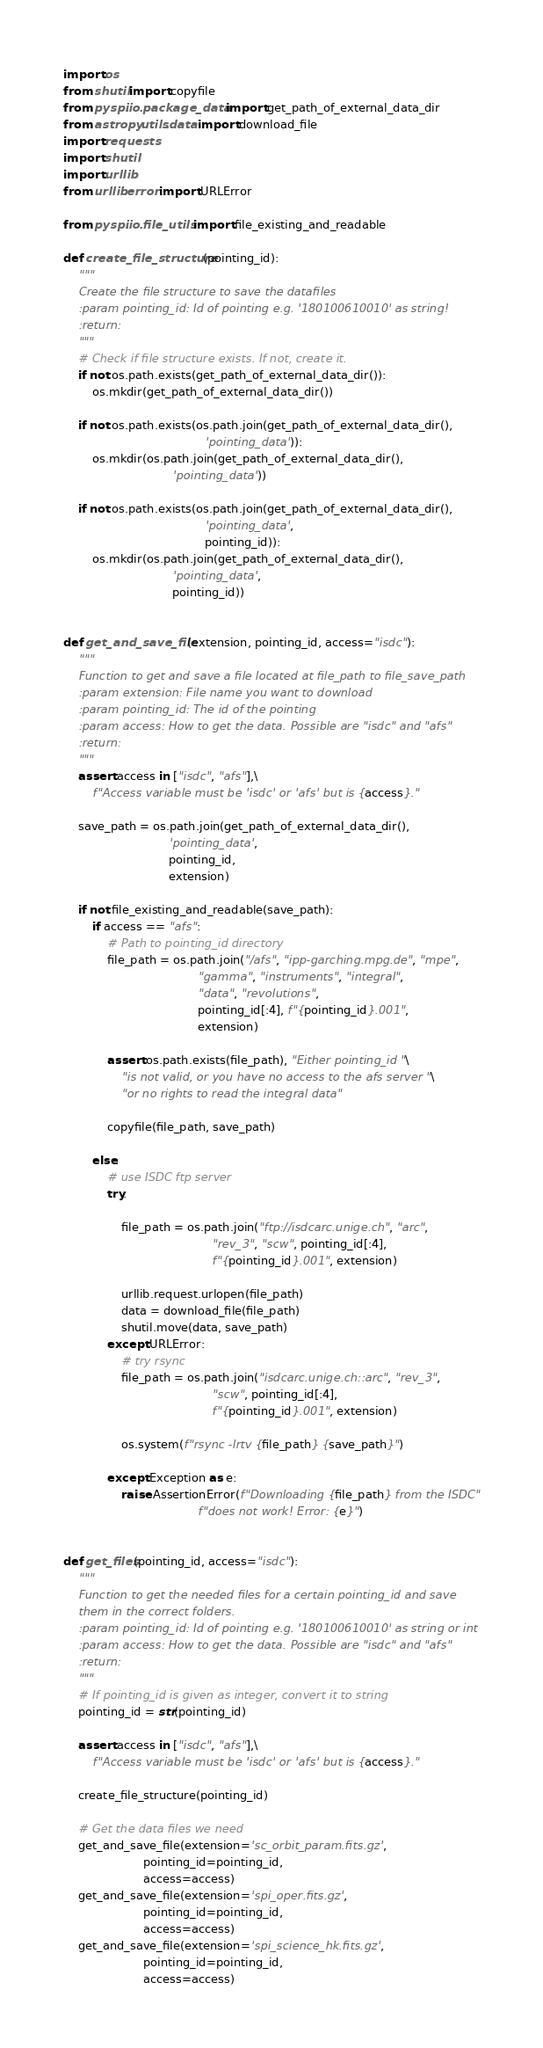Convert code to text. <code><loc_0><loc_0><loc_500><loc_500><_Python_>import os
from shutil import copyfile
from pyspi.io.package_data import get_path_of_external_data_dir
from astropy.utils.data import download_file
import requests
import shutil
import urllib
from urllib.error import URLError

from pyspi.io.file_utils import file_existing_and_readable

def create_file_structure(pointing_id):
    """
    Create the file structure to save the datafiles
    :param pointing_id: Id of pointing e.g. '180100610010' as string!
    :return:
    """
    # Check if file structure exists. If not, create it.
    if not os.path.exists(get_path_of_external_data_dir()):
        os.mkdir(get_path_of_external_data_dir())

    if not os.path.exists(os.path.join(get_path_of_external_data_dir(),
                                       'pointing_data')):
        os.mkdir(os.path.join(get_path_of_external_data_dir(),
                              'pointing_data'))

    if not os.path.exists(os.path.join(get_path_of_external_data_dir(),
                                       'pointing_data',
                                       pointing_id)):
        os.mkdir(os.path.join(get_path_of_external_data_dir(),
                              'pointing_data',
                              pointing_id))


def get_and_save_file(extension, pointing_id, access="isdc"):
    """
    Function to get and save a file located at file_path to file_save_path
    :param extension: File name you want to download
    :param pointing_id: The id of the pointing
    :param access: How to get the data. Possible are "isdc" and "afs"
    :return:
    """
    assert access in ["isdc", "afs"],\
        f"Access variable must be 'isdc' or 'afs' but is {access}."

    save_path = os.path.join(get_path_of_external_data_dir(),
                             'pointing_data',
                             pointing_id,
                             extension)

    if not file_existing_and_readable(save_path):
        if access == "afs":
            # Path to pointing_id directory
            file_path = os.path.join("/afs", "ipp-garching.mpg.de", "mpe",
                                     "gamma", "instruments", "integral",
                                     "data", "revolutions",
                                     pointing_id[:4], f"{pointing_id}.001",
                                     extension)

            assert os.path.exists(file_path), "Either pointing_id "\
                "is not valid, or you have no access to the afs server "\
                "or no rights to read the integral data"

            copyfile(file_path, save_path)

        else:
            # use ISDC ftp server
            try:

                file_path = os.path.join("ftp://isdcarc.unige.ch", "arc",
                                         "rev_3", "scw", pointing_id[:4],
                                         f"{pointing_id}.001", extension)

                urllib.request.urlopen(file_path)
                data = download_file(file_path)
                shutil.move(data, save_path)
            except URLError:
                # try rsync
                file_path = os.path.join("isdcarc.unige.ch::arc", "rev_3",
                                         "scw", pointing_id[:4],
                                         f"{pointing_id}.001", extension)

                os.system(f"rsync -lrtv {file_path} {save_path}")

            except Exception as e:
                raise AssertionError(f"Downloading {file_path} from the ISDC"
                                     f"does not work! Error: {e}")


def get_files(pointing_id, access="isdc"):
    """
    Function to get the needed files for a certain pointing_id and save
    them in the correct folders.
    :param pointing_id: Id of pointing e.g. '180100610010' as string or int
    :param access: How to get the data. Possible are "isdc" and "afs"
    :return:
    """
    # If pointing_id is given as integer, convert it to string
    pointing_id = str(pointing_id)

    assert access in ["isdc", "afs"],\
        f"Access variable must be 'isdc' or 'afs' but is {access}."

    create_file_structure(pointing_id)

    # Get the data files we need
    get_and_save_file(extension='sc_orbit_param.fits.gz',
                      pointing_id=pointing_id,
                      access=access)
    get_and_save_file(extension='spi_oper.fits.gz',
                      pointing_id=pointing_id,
                      access=access)
    get_and_save_file(extension='spi_science_hk.fits.gz',
                      pointing_id=pointing_id,
                      access=access)
</code> 